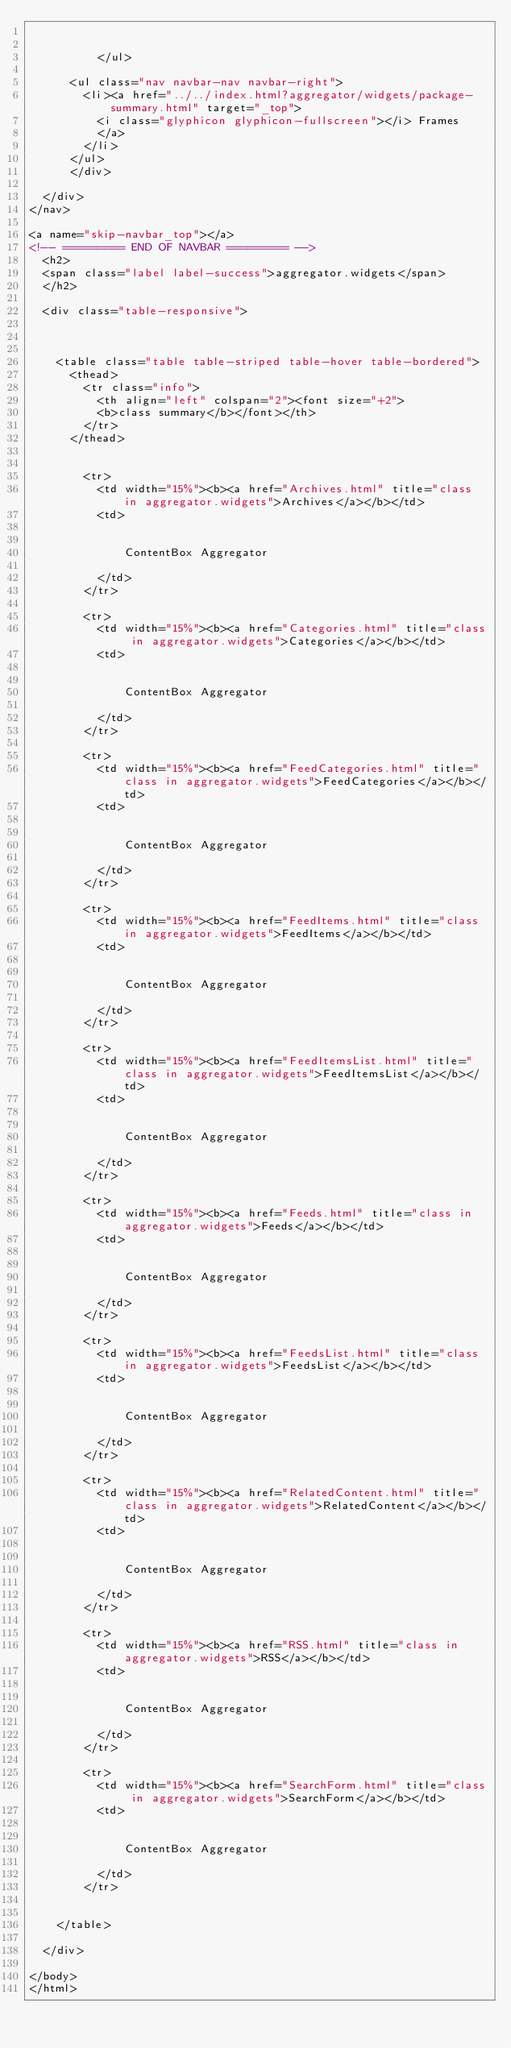Convert code to text. <code><loc_0><loc_0><loc_500><loc_500><_HTML_>
			  	
	      	</ul>

			<ul class="nav navbar-nav navbar-right">
				<li><a href="../../index.html?aggregator/widgets/package-summary.html" target="_top">
					<i class="glyphicon glyphicon-fullscreen"></i> Frames
					</a>
				</li>
			</ul>
	    </div>

	</div>
</nav>	

<a name="skip-navbar_top"></a>
<!-- ========= END OF NAVBAR ========= -->
	<h2>
	<span class="label label-success">aggregator.widgets</span>
	</h2>
	
	<div class="table-responsive">
	
	
	
		<table class="table table-striped table-hover table-bordered">
			<thead>
				<tr class="info">
					<th align="left" colspan="2"><font size="+2">
					<b>class summary</b></font></th>
				</tr>
			</thead>
	
			
				<tr>
					<td width="15%"><b><a href="Archives.html" title="class in aggregator.widgets">Archives</a></b></td>
					<td>
						
						
							ContentBox Aggregator
						
					</td>
				</tr>
			
				<tr>
					<td width="15%"><b><a href="Categories.html" title="class in aggregator.widgets">Categories</a></b></td>
					<td>
						
						
							ContentBox Aggregator
						
					</td>
				</tr>
			
				<tr>
					<td width="15%"><b><a href="FeedCategories.html" title="class in aggregator.widgets">FeedCategories</a></b></td>
					<td>
						
						
							ContentBox Aggregator
						
					</td>
				</tr>
			
				<tr>
					<td width="15%"><b><a href="FeedItems.html" title="class in aggregator.widgets">FeedItems</a></b></td>
					<td>
						
						
							ContentBox Aggregator
						
					</td>
				</tr>
			
				<tr>
					<td width="15%"><b><a href="FeedItemsList.html" title="class in aggregator.widgets">FeedItemsList</a></b></td>
					<td>
						
						
							ContentBox Aggregator
						
					</td>
				</tr>
			
				<tr>
					<td width="15%"><b><a href="Feeds.html" title="class in aggregator.widgets">Feeds</a></b></td>
					<td>
						
						
							ContentBox Aggregator
						
					</td>
				</tr>
			
				<tr>
					<td width="15%"><b><a href="FeedsList.html" title="class in aggregator.widgets">FeedsList</a></b></td>
					<td>
						
						
							ContentBox Aggregator
						
					</td>
				</tr>
			
				<tr>
					<td width="15%"><b><a href="RelatedContent.html" title="class in aggregator.widgets">RelatedContent</a></b></td>
					<td>
						
						
							ContentBox Aggregator
						
					</td>
				</tr>
			
				<tr>
					<td width="15%"><b><a href="RSS.html" title="class in aggregator.widgets">RSS</a></b></td>
					<td>
						
						
							ContentBox Aggregator
						
					</td>
				</tr>
			
				<tr>
					<td width="15%"><b><a href="SearchForm.html" title="class in aggregator.widgets">SearchForm</a></b></td>
					<td>
						
						
							ContentBox Aggregator
						
					</td>
				</tr>
			
	
		</table>
	
	</div>

</body>
</html>
</code> 